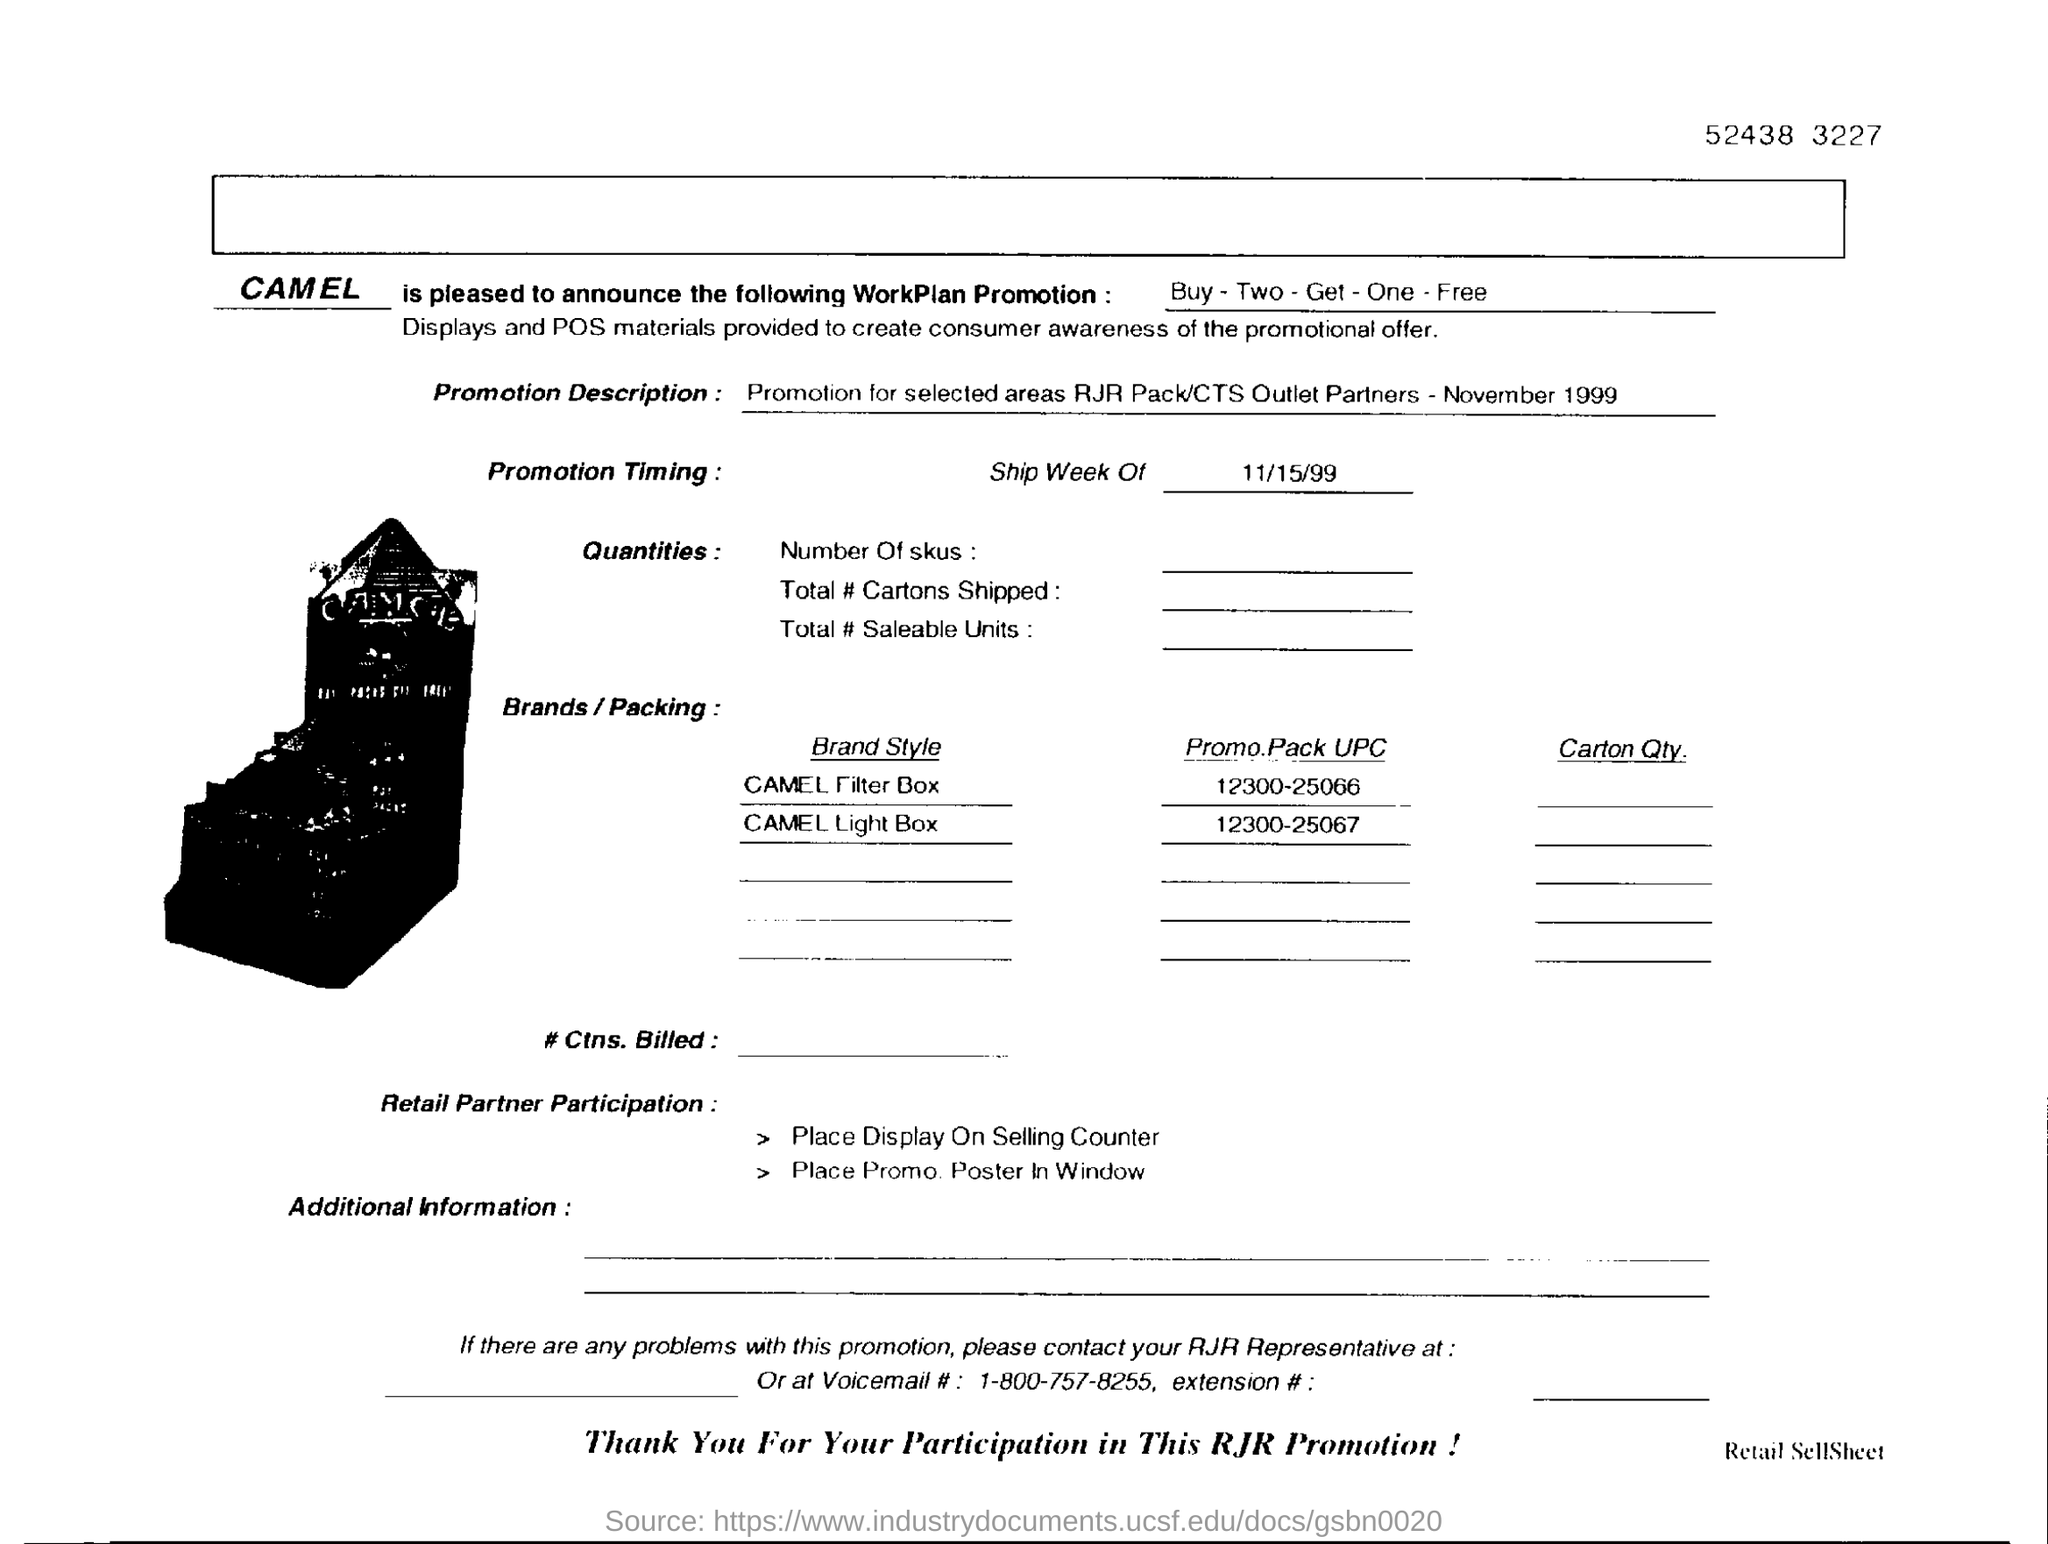What is digit shown at the top right corner?
Your answer should be very brief. 52438 3227. What is the workplan promotion?
Make the answer very short. Buy - Two - Get - One - Free. What is the ship week of date given in the form?
Your answer should be very brief. 11/15/99. 